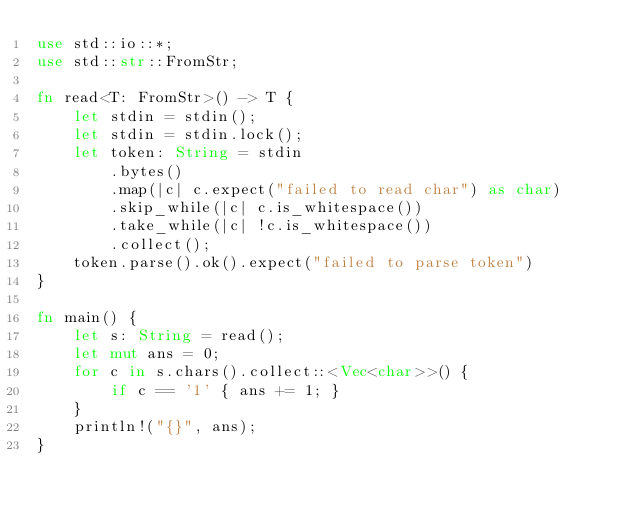<code> <loc_0><loc_0><loc_500><loc_500><_Rust_>use std::io::*;
use std::str::FromStr;
 
fn read<T: FromStr>() -> T {
    let stdin = stdin();
    let stdin = stdin.lock();
    let token: String = stdin
        .bytes()
        .map(|c| c.expect("failed to read char") as char)
        .skip_while(|c| c.is_whitespace())
        .take_while(|c| !c.is_whitespace())
        .collect();
    token.parse().ok().expect("failed to parse token")
}
 
fn main() {
    let s: String = read();
    let mut ans = 0;
    for c in s.chars().collect::<Vec<char>>() {
        if c == '1' { ans += 1; }
    }
    println!("{}", ans);
}</code> 